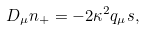<formula> <loc_0><loc_0><loc_500><loc_500>D _ { \mu } n _ { + } = - 2 \kappa ^ { 2 } q _ { \mu } s ,</formula> 